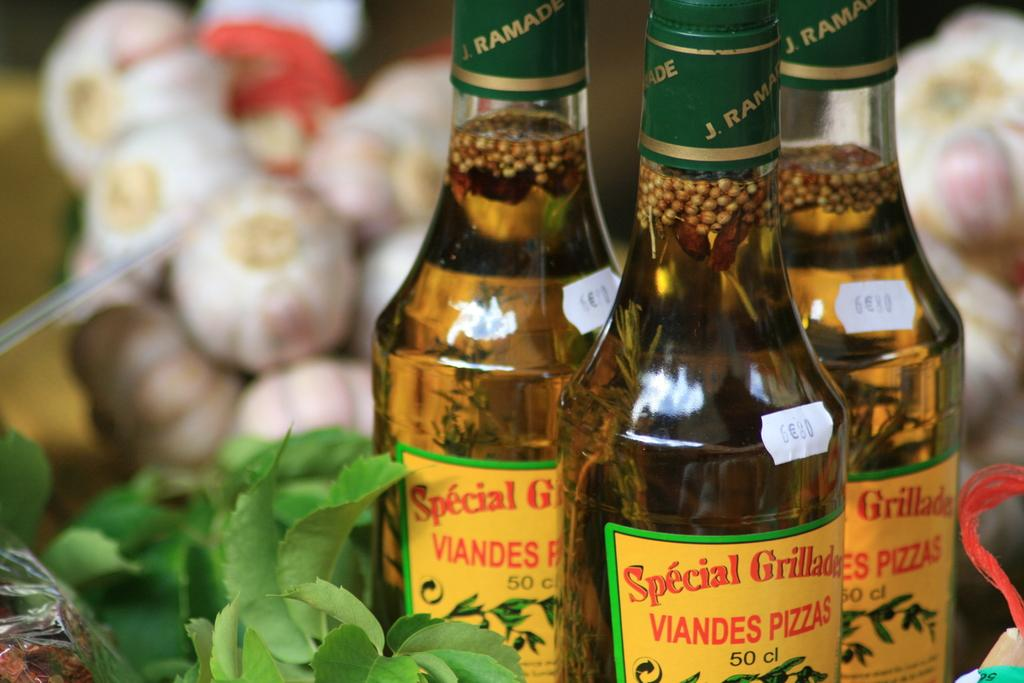How many bottles are visible in the image? There are three bottles in the image. What else can be seen in the image besides the bottles? In the background of the image, there are vegetables visible. Where is the sofa located in the image? There is no sofa present in the image. What type of face can be seen on the vegetables in the image? There are no faces on the vegetables in the image; they are simply vegetables in the background. 